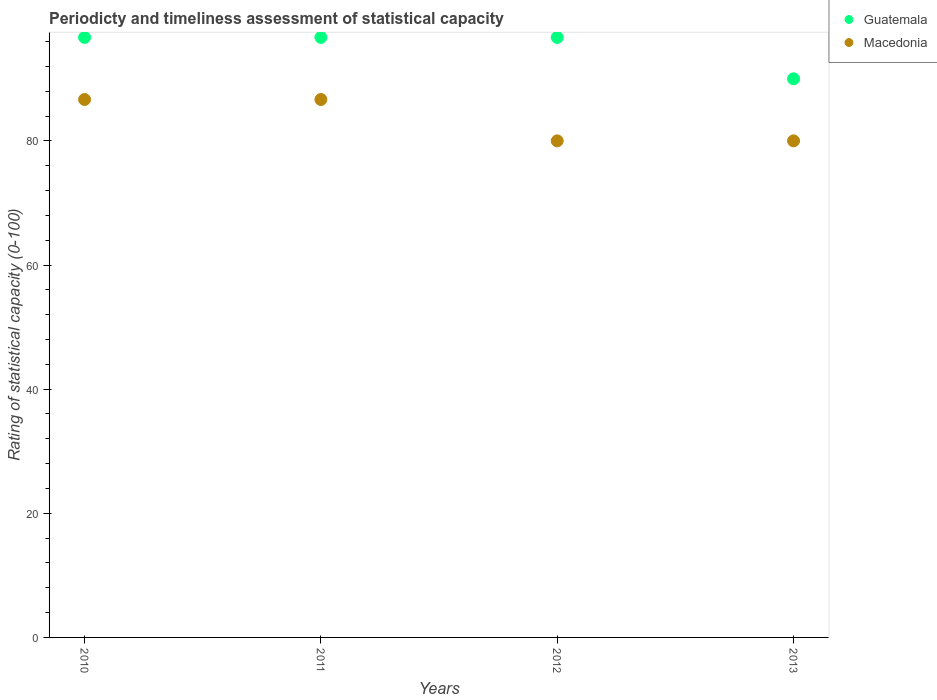How many different coloured dotlines are there?
Provide a succinct answer. 2. Across all years, what is the maximum rating of statistical capacity in Macedonia?
Give a very brief answer. 86.67. In which year was the rating of statistical capacity in Macedonia maximum?
Ensure brevity in your answer.  2010. What is the total rating of statistical capacity in Guatemala in the graph?
Keep it short and to the point. 380. What is the difference between the rating of statistical capacity in Guatemala in 2010 and that in 2013?
Make the answer very short. 6.67. What is the difference between the rating of statistical capacity in Macedonia in 2013 and the rating of statistical capacity in Guatemala in 2010?
Offer a terse response. -16.67. What is the average rating of statistical capacity in Macedonia per year?
Give a very brief answer. 83.33. In the year 2013, what is the difference between the rating of statistical capacity in Guatemala and rating of statistical capacity in Macedonia?
Offer a very short reply. 10. Is the difference between the rating of statistical capacity in Guatemala in 2010 and 2013 greater than the difference between the rating of statistical capacity in Macedonia in 2010 and 2013?
Give a very brief answer. No. What is the difference between the highest and the second highest rating of statistical capacity in Guatemala?
Keep it short and to the point. 0. What is the difference between the highest and the lowest rating of statistical capacity in Guatemala?
Your response must be concise. 6.67. In how many years, is the rating of statistical capacity in Guatemala greater than the average rating of statistical capacity in Guatemala taken over all years?
Provide a short and direct response. 3. Does the rating of statistical capacity in Guatemala monotonically increase over the years?
Your answer should be very brief. No. Is the rating of statistical capacity in Macedonia strictly less than the rating of statistical capacity in Guatemala over the years?
Provide a succinct answer. Yes. How many dotlines are there?
Your answer should be very brief. 2. How many years are there in the graph?
Offer a very short reply. 4. What is the difference between two consecutive major ticks on the Y-axis?
Give a very brief answer. 20. Does the graph contain any zero values?
Your answer should be compact. No. How many legend labels are there?
Your answer should be very brief. 2. What is the title of the graph?
Keep it short and to the point. Periodicty and timeliness assessment of statistical capacity. What is the label or title of the X-axis?
Your answer should be very brief. Years. What is the label or title of the Y-axis?
Your answer should be compact. Rating of statistical capacity (0-100). What is the Rating of statistical capacity (0-100) in Guatemala in 2010?
Provide a succinct answer. 96.67. What is the Rating of statistical capacity (0-100) of Macedonia in 2010?
Your answer should be very brief. 86.67. What is the Rating of statistical capacity (0-100) of Guatemala in 2011?
Make the answer very short. 96.67. What is the Rating of statistical capacity (0-100) in Macedonia in 2011?
Your answer should be compact. 86.67. What is the Rating of statistical capacity (0-100) in Guatemala in 2012?
Provide a short and direct response. 96.67. What is the Rating of statistical capacity (0-100) in Guatemala in 2013?
Your response must be concise. 90. Across all years, what is the maximum Rating of statistical capacity (0-100) of Guatemala?
Keep it short and to the point. 96.67. Across all years, what is the maximum Rating of statistical capacity (0-100) of Macedonia?
Keep it short and to the point. 86.67. Across all years, what is the minimum Rating of statistical capacity (0-100) of Guatemala?
Ensure brevity in your answer.  90. Across all years, what is the minimum Rating of statistical capacity (0-100) of Macedonia?
Provide a short and direct response. 80. What is the total Rating of statistical capacity (0-100) in Guatemala in the graph?
Provide a short and direct response. 380. What is the total Rating of statistical capacity (0-100) of Macedonia in the graph?
Provide a short and direct response. 333.33. What is the difference between the Rating of statistical capacity (0-100) of Guatemala in 2010 and that in 2011?
Offer a very short reply. 0. What is the difference between the Rating of statistical capacity (0-100) in Guatemala in 2010 and that in 2012?
Ensure brevity in your answer.  0. What is the difference between the Rating of statistical capacity (0-100) in Macedonia in 2010 and that in 2012?
Provide a short and direct response. 6.67. What is the difference between the Rating of statistical capacity (0-100) of Guatemala in 2010 and that in 2013?
Your answer should be very brief. 6.67. What is the difference between the Rating of statistical capacity (0-100) in Guatemala in 2011 and that in 2012?
Give a very brief answer. 0. What is the difference between the Rating of statistical capacity (0-100) of Macedonia in 2011 and that in 2012?
Your answer should be compact. 6.67. What is the difference between the Rating of statistical capacity (0-100) of Guatemala in 2011 and that in 2013?
Make the answer very short. 6.67. What is the difference between the Rating of statistical capacity (0-100) of Macedonia in 2011 and that in 2013?
Give a very brief answer. 6.67. What is the difference between the Rating of statistical capacity (0-100) in Macedonia in 2012 and that in 2013?
Provide a succinct answer. 0. What is the difference between the Rating of statistical capacity (0-100) of Guatemala in 2010 and the Rating of statistical capacity (0-100) of Macedonia in 2012?
Your response must be concise. 16.67. What is the difference between the Rating of statistical capacity (0-100) in Guatemala in 2010 and the Rating of statistical capacity (0-100) in Macedonia in 2013?
Give a very brief answer. 16.67. What is the difference between the Rating of statistical capacity (0-100) of Guatemala in 2011 and the Rating of statistical capacity (0-100) of Macedonia in 2012?
Your response must be concise. 16.67. What is the difference between the Rating of statistical capacity (0-100) in Guatemala in 2011 and the Rating of statistical capacity (0-100) in Macedonia in 2013?
Keep it short and to the point. 16.67. What is the difference between the Rating of statistical capacity (0-100) of Guatemala in 2012 and the Rating of statistical capacity (0-100) of Macedonia in 2013?
Provide a short and direct response. 16.67. What is the average Rating of statistical capacity (0-100) of Guatemala per year?
Offer a terse response. 95. What is the average Rating of statistical capacity (0-100) of Macedonia per year?
Provide a short and direct response. 83.33. In the year 2010, what is the difference between the Rating of statistical capacity (0-100) in Guatemala and Rating of statistical capacity (0-100) in Macedonia?
Your answer should be very brief. 10. In the year 2011, what is the difference between the Rating of statistical capacity (0-100) of Guatemala and Rating of statistical capacity (0-100) of Macedonia?
Ensure brevity in your answer.  10. In the year 2012, what is the difference between the Rating of statistical capacity (0-100) of Guatemala and Rating of statistical capacity (0-100) of Macedonia?
Your response must be concise. 16.67. In the year 2013, what is the difference between the Rating of statistical capacity (0-100) of Guatemala and Rating of statistical capacity (0-100) of Macedonia?
Your response must be concise. 10. What is the ratio of the Rating of statistical capacity (0-100) in Guatemala in 2010 to that in 2011?
Make the answer very short. 1. What is the ratio of the Rating of statistical capacity (0-100) in Macedonia in 2010 to that in 2011?
Provide a short and direct response. 1. What is the ratio of the Rating of statistical capacity (0-100) in Guatemala in 2010 to that in 2012?
Offer a very short reply. 1. What is the ratio of the Rating of statistical capacity (0-100) in Macedonia in 2010 to that in 2012?
Your answer should be compact. 1.08. What is the ratio of the Rating of statistical capacity (0-100) of Guatemala in 2010 to that in 2013?
Give a very brief answer. 1.07. What is the ratio of the Rating of statistical capacity (0-100) of Guatemala in 2011 to that in 2012?
Offer a terse response. 1. What is the ratio of the Rating of statistical capacity (0-100) in Macedonia in 2011 to that in 2012?
Your answer should be compact. 1.08. What is the ratio of the Rating of statistical capacity (0-100) in Guatemala in 2011 to that in 2013?
Give a very brief answer. 1.07. What is the ratio of the Rating of statistical capacity (0-100) of Macedonia in 2011 to that in 2013?
Keep it short and to the point. 1.08. What is the ratio of the Rating of statistical capacity (0-100) of Guatemala in 2012 to that in 2013?
Ensure brevity in your answer.  1.07. What is the ratio of the Rating of statistical capacity (0-100) of Macedonia in 2012 to that in 2013?
Keep it short and to the point. 1. What is the difference between the highest and the second highest Rating of statistical capacity (0-100) in Guatemala?
Your answer should be compact. 0. 